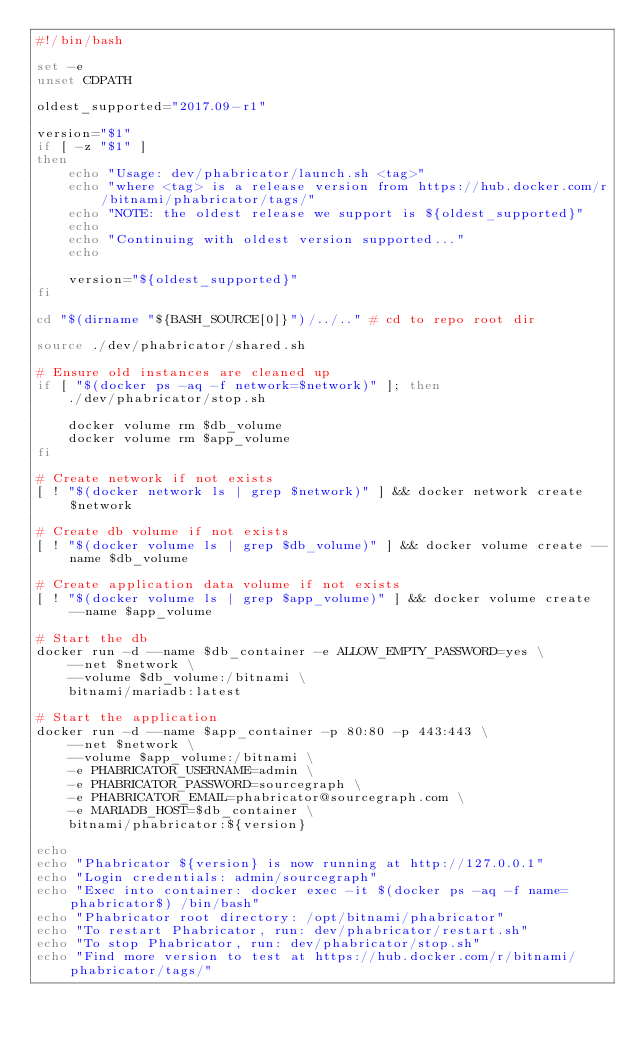Convert code to text. <code><loc_0><loc_0><loc_500><loc_500><_Bash_>#!/bin/bash

set -e
unset CDPATH

oldest_supported="2017.09-r1"

version="$1"
if [ -z "$1" ]
then
    echo "Usage: dev/phabricator/launch.sh <tag>"
    echo "where <tag> is a release version from https://hub.docker.com/r/bitnami/phabricator/tags/"
    echo "NOTE: the oldest release we support is ${oldest_supported}"
    echo
    echo "Continuing with oldest version supported..."
    echo

    version="${oldest_supported}"
fi

cd "$(dirname "${BASH_SOURCE[0]}")/../.." # cd to repo root dir

source ./dev/phabricator/shared.sh

# Ensure old instances are cleaned up
if [ "$(docker ps -aq -f network=$network)" ]; then
    ./dev/phabricator/stop.sh

    docker volume rm $db_volume
    docker volume rm $app_volume
fi

# Create network if not exists
[ ! "$(docker network ls | grep $network)" ] && docker network create $network

# Create db volume if not exists
[ ! "$(docker volume ls | grep $db_volume)" ] && docker volume create --name $db_volume

# Create application data volume if not exists
[ ! "$(docker volume ls | grep $app_volume)" ] && docker volume create --name $app_volume

# Start the db
docker run -d --name $db_container -e ALLOW_EMPTY_PASSWORD=yes \
    --net $network \
    --volume $db_volume:/bitnami \
    bitnami/mariadb:latest

# Start the application
docker run -d --name $app_container -p 80:80 -p 443:443 \
    --net $network \
    --volume $app_volume:/bitnami \
    -e PHABRICATOR_USERNAME=admin \
    -e PHABRICATOR_PASSWORD=sourcegraph \
    -e PHABRICATOR_EMAIL=phabricator@sourcegraph.com \
    -e MARIADB_HOST=$db_container \
    bitnami/phabricator:${version}

echo
echo "Phabricator ${version} is now running at http://127.0.0.1"
echo "Login credentials: admin/sourcegraph"
echo "Exec into container: docker exec -it $(docker ps -aq -f name=phabricator$) /bin/bash"
echo "Phabricator root directory: /opt/bitnami/phabricator"
echo "To restart Phabricator, run: dev/phabricator/restart.sh"
echo "To stop Phabricator, run: dev/phabricator/stop.sh"
echo "Find more version to test at https://hub.docker.com/r/bitnami/phabricator/tags/"
</code> 